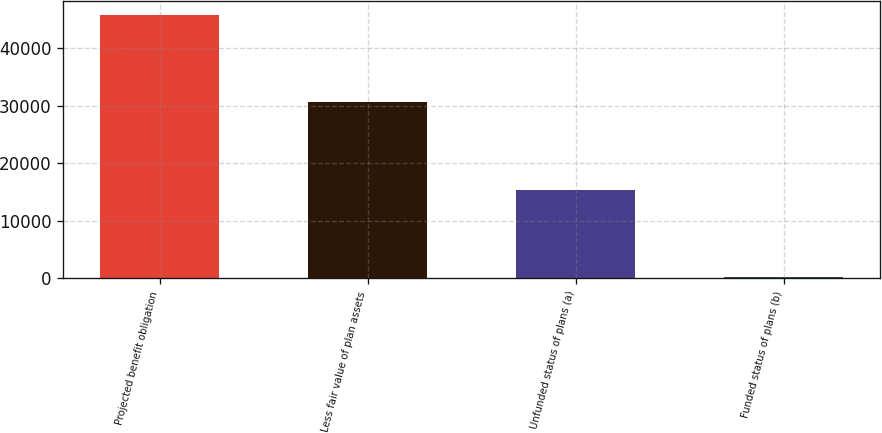<chart> <loc_0><loc_0><loc_500><loc_500><bar_chart><fcel>Projected benefit obligation<fcel>Less fair value of plan assets<fcel>Unfunded status of plans (a)<fcel>Funded status of plans (b)<nl><fcel>45875<fcel>30597<fcel>15278<fcel>185<nl></chart> 